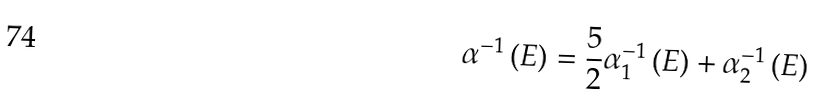<formula> <loc_0><loc_0><loc_500><loc_500>\alpha ^ { - 1 } \left ( E \right ) = \frac { 5 } { 2 } \alpha _ { 1 } ^ { - 1 } \left ( E \right ) + \alpha _ { 2 } ^ { - 1 } \left ( E \right )</formula> 